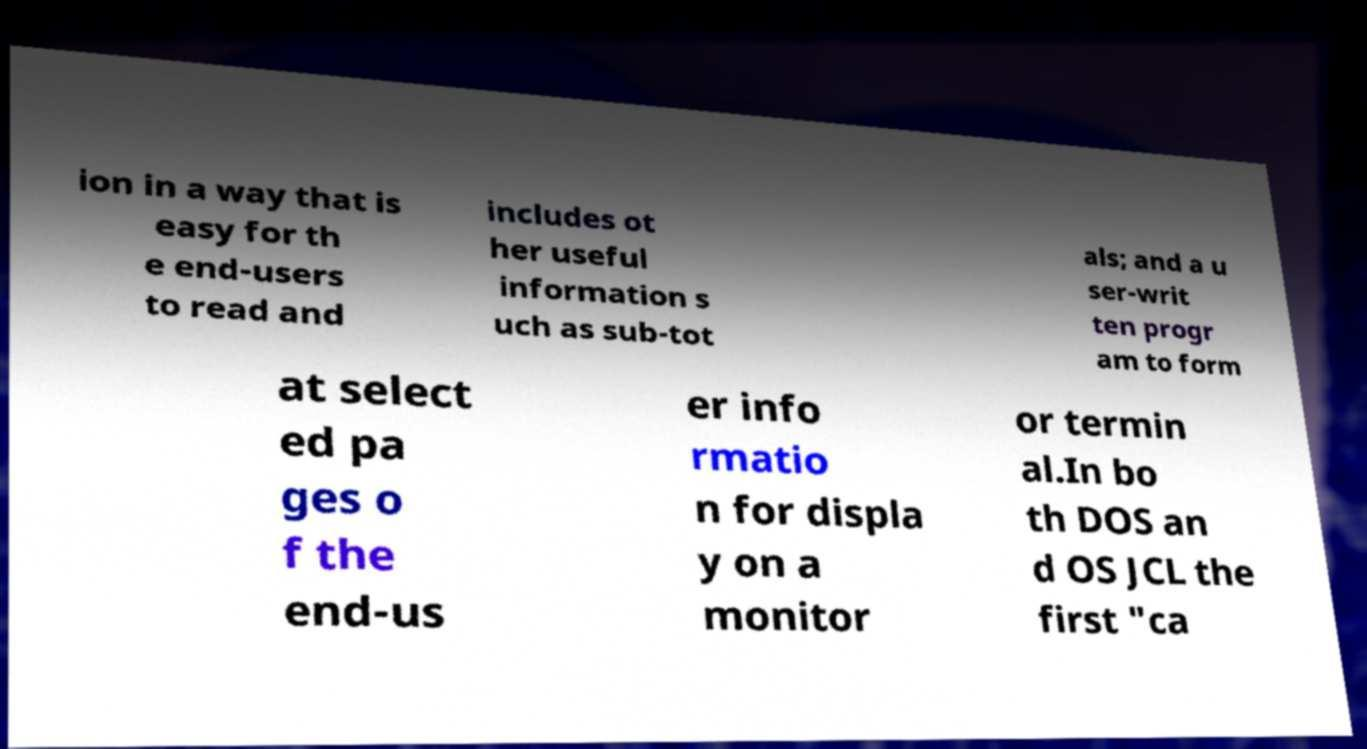Can you read and provide the text displayed in the image?This photo seems to have some interesting text. Can you extract and type it out for me? ion in a way that is easy for th e end-users to read and includes ot her useful information s uch as sub-tot als; and a u ser-writ ten progr am to form at select ed pa ges o f the end-us er info rmatio n for displa y on a monitor or termin al.In bo th DOS an d OS JCL the first "ca 